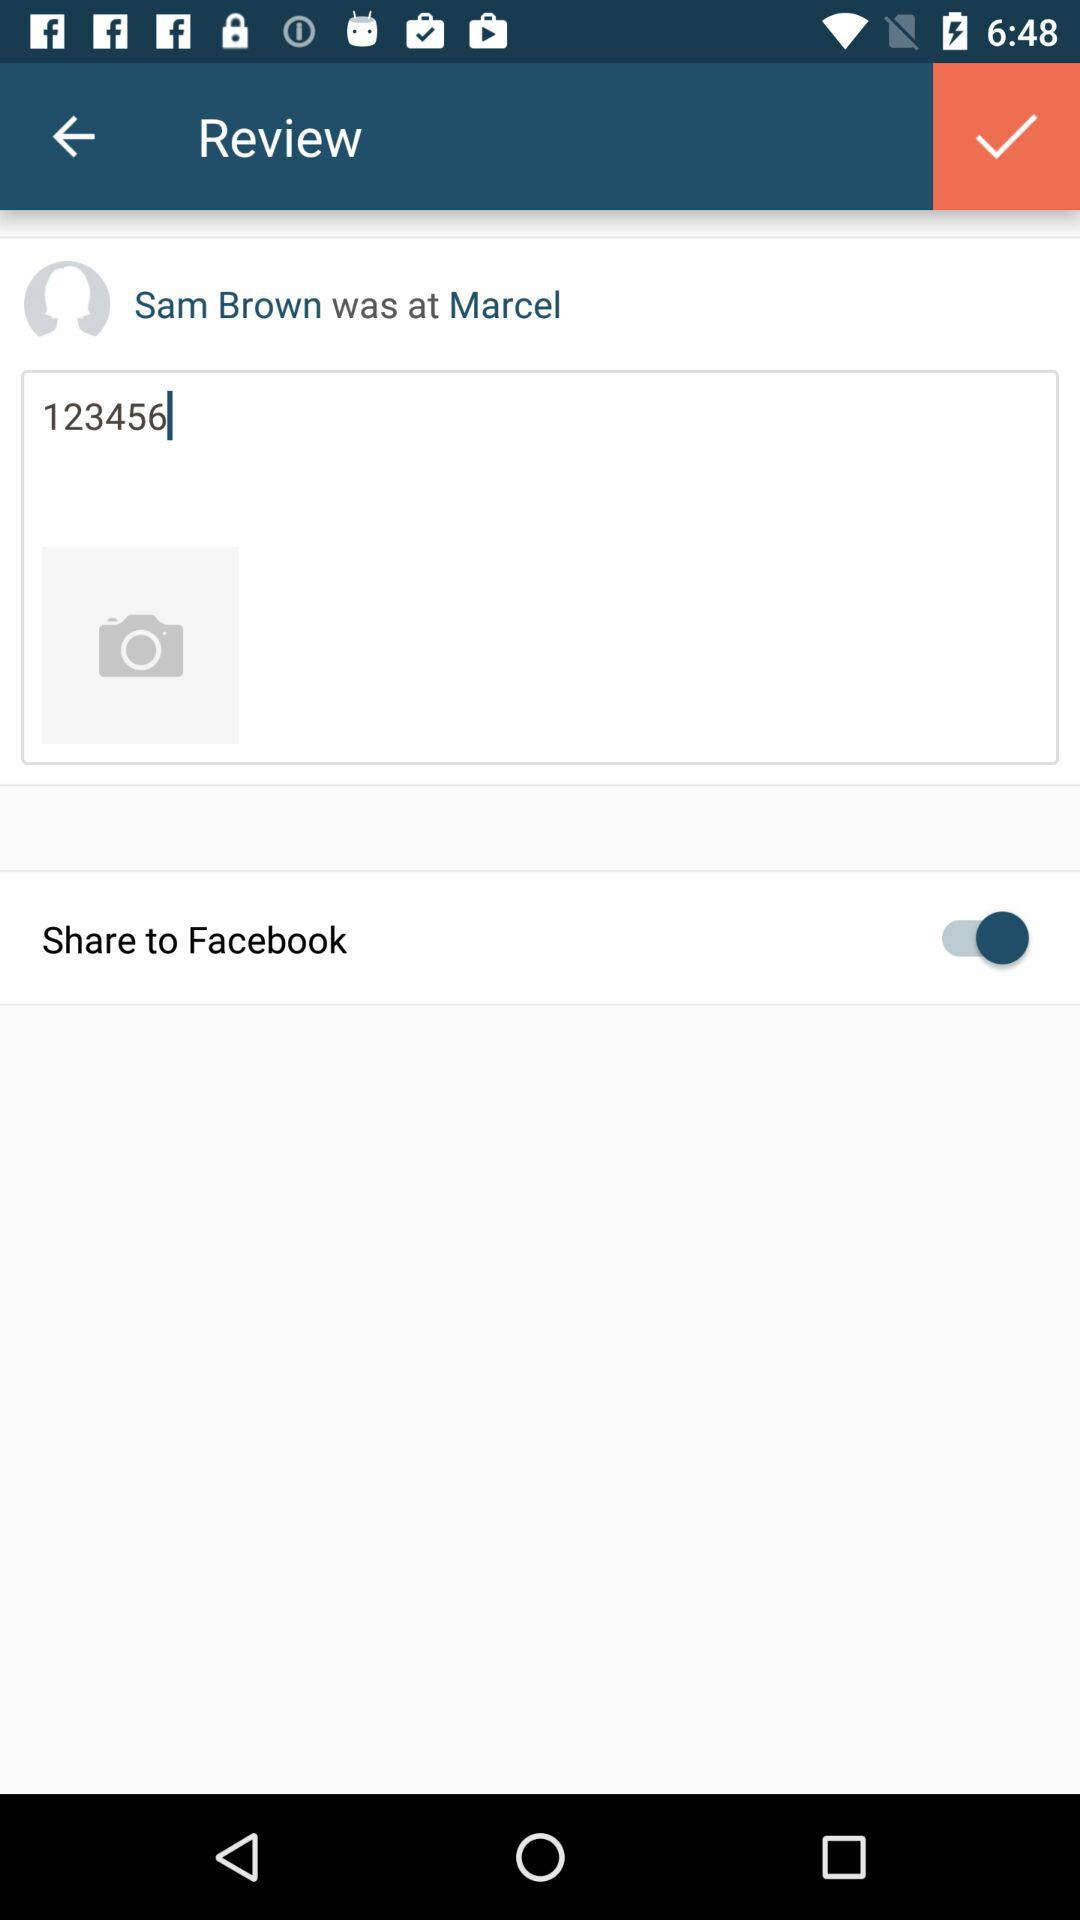What is the name of the user? The name of the user is Sam Brown. 